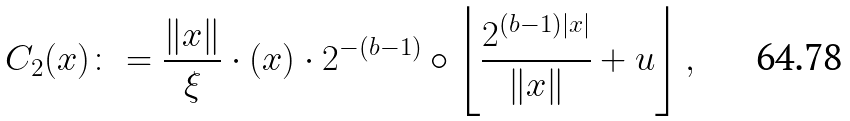<formula> <loc_0><loc_0><loc_500><loc_500>C _ { 2 } ( x ) \colon = \frac { \| x \| } { \xi } \cdot ( x ) \cdot 2 ^ { - ( b - 1 ) } \circ \left \lfloor \frac { 2 ^ { ( b - 1 ) | x | } } { \| x \| } + u \right \rfloor ,</formula> 